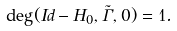Convert formula to latex. <formula><loc_0><loc_0><loc_500><loc_500>\deg ( I d - H _ { 0 } , \tilde { \Gamma } , 0 ) = 1 .</formula> 